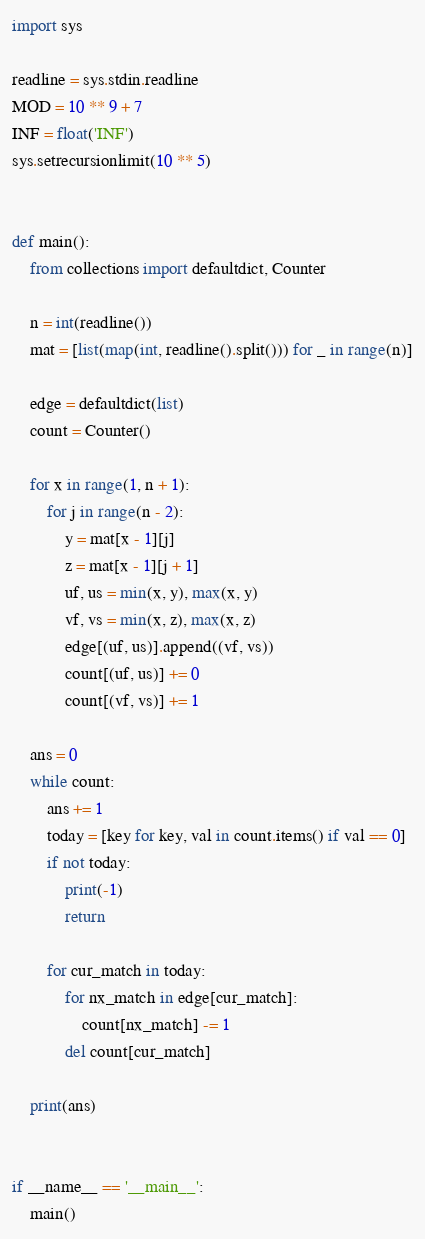Convert code to text. <code><loc_0><loc_0><loc_500><loc_500><_Python_>import sys

readline = sys.stdin.readline
MOD = 10 ** 9 + 7
INF = float('INF')
sys.setrecursionlimit(10 ** 5)


def main():
    from collections import defaultdict, Counter

    n = int(readline())
    mat = [list(map(int, readline().split())) for _ in range(n)]

    edge = defaultdict(list)
    count = Counter()

    for x in range(1, n + 1):
        for j in range(n - 2):
            y = mat[x - 1][j]
            z = mat[x - 1][j + 1]
            uf, us = min(x, y), max(x, y)
            vf, vs = min(x, z), max(x, z)
            edge[(uf, us)].append((vf, vs))
            count[(uf, us)] += 0
            count[(vf, vs)] += 1

    ans = 0
    while count:
        ans += 1
        today = [key for key, val in count.items() if val == 0]
        if not today:
            print(-1)
            return

        for cur_match in today:
            for nx_match in edge[cur_match]:
                count[nx_match] -= 1
            del count[cur_match]

    print(ans)


if __name__ == '__main__':
    main()
</code> 